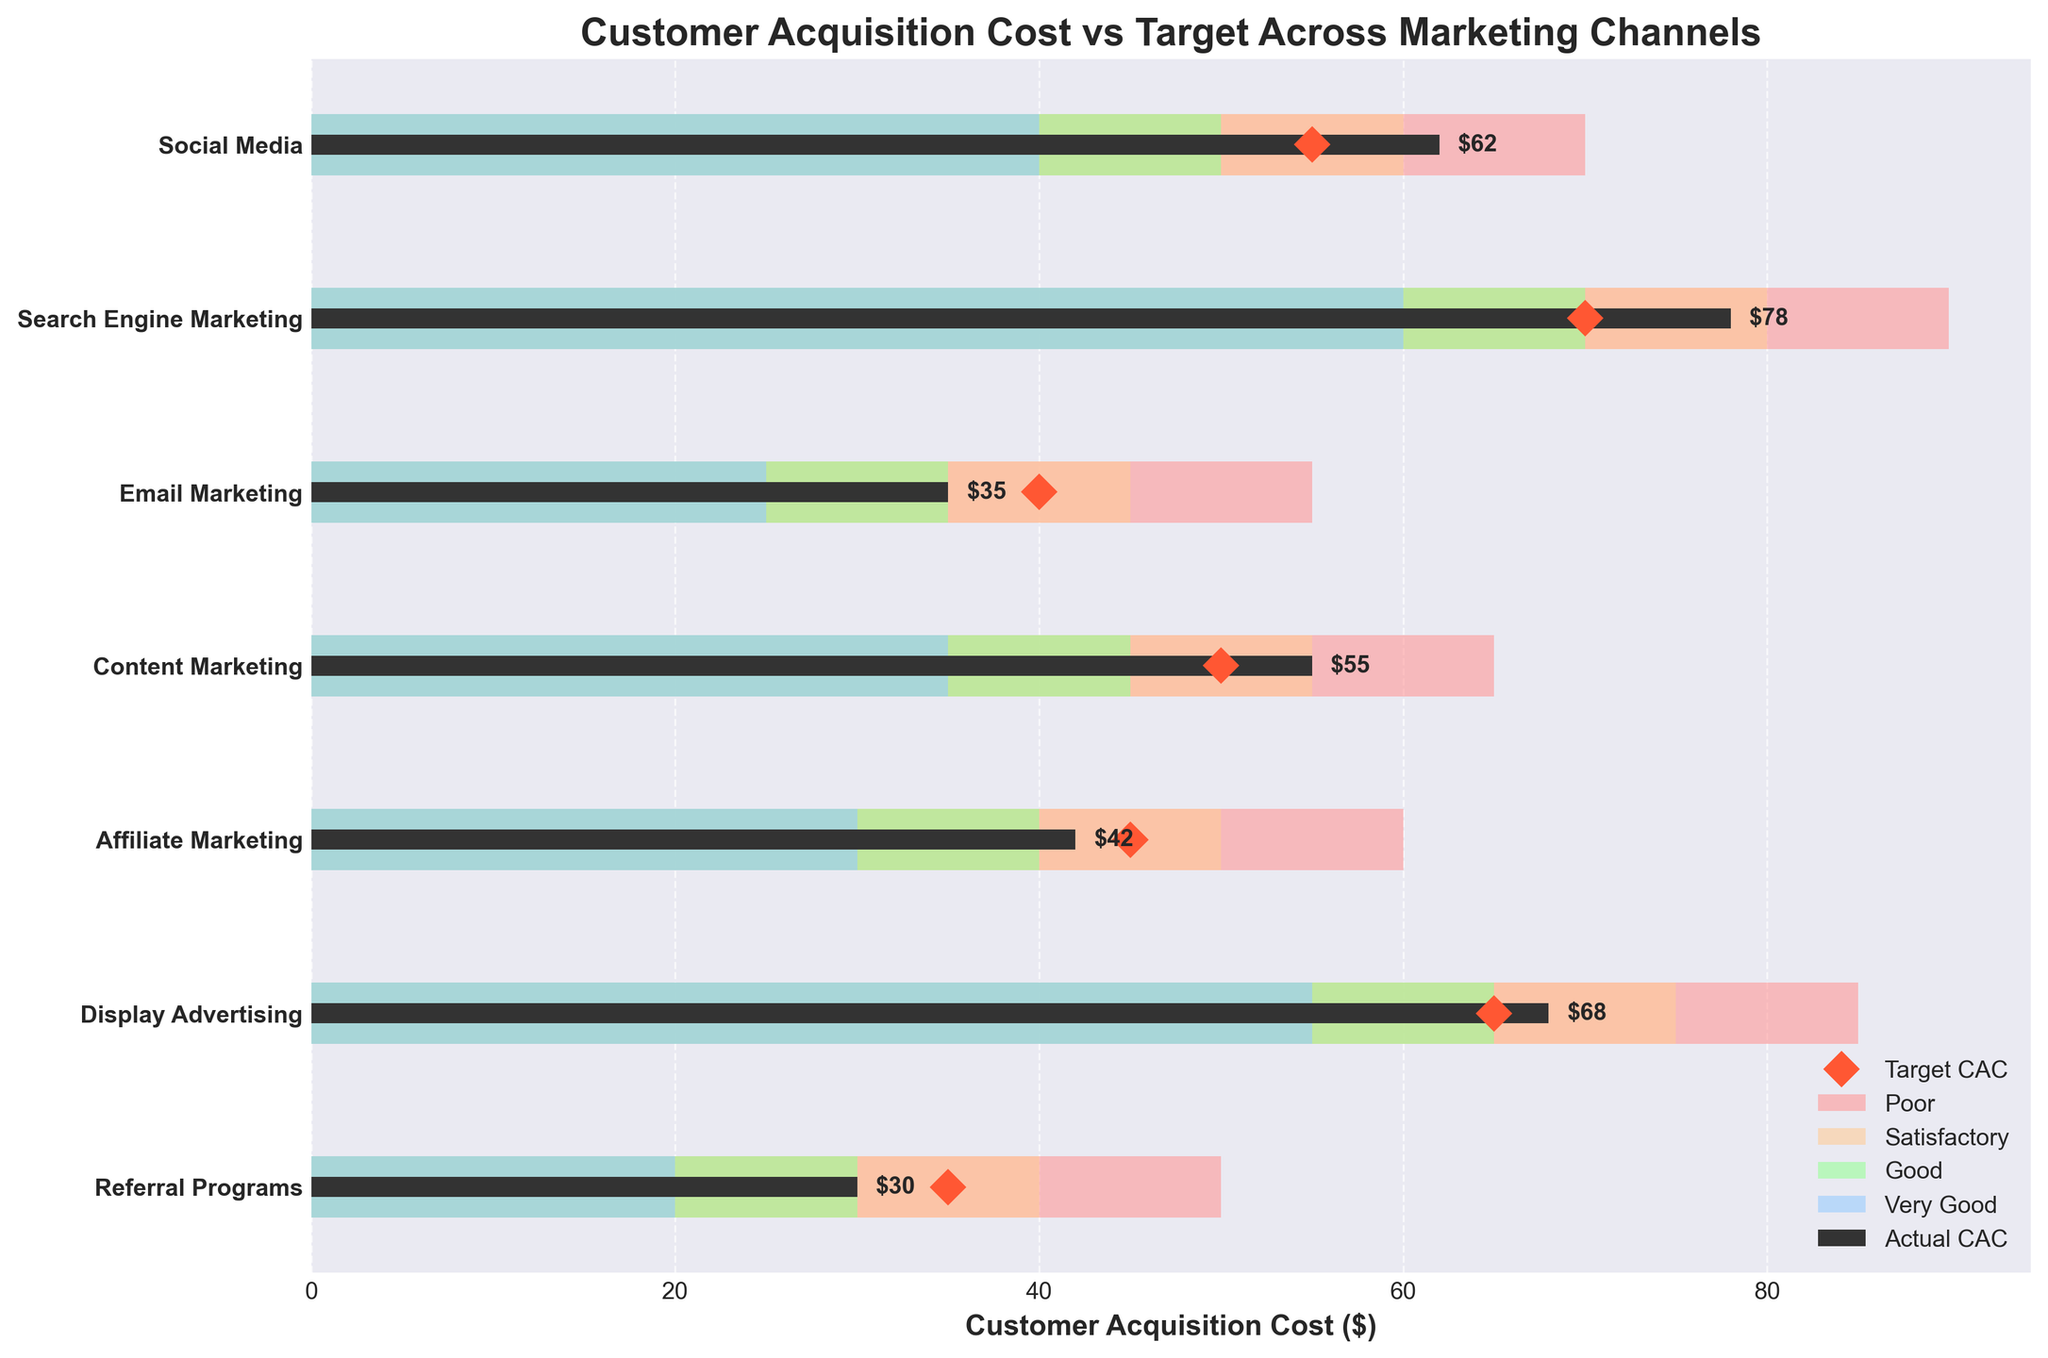What is the title of the figure? The title of the figure is displayed at the top. It describes the purpose or the main message the plot conveys.
Answer: Customer Acquisition Cost vs Target Across Marketing Channels Which marketing channel has the highest actual Customer Acquisition Cost (CAC)? By looking at the horizontal bars representing the actual CAC in dark color, we can identify the highest bar to find the channel with the highest CAC.
Answer: Search Engine Marketing What is the target CAC for Social Media? The target CAC is marked by a diamond shape for each channel, and we need to find the diamond corresponding to Social Media.
Answer: 55 Compare the actual CAC for Email Marketing and Content Marketing. Which one is lower? By observing the lengths of the horizontal bars representing the actual CAC for both channels, we can see which bar is shorter.
Answer: Email Marketing Which marketing channel has the actual CAC closest to the target CAC? By comparing the positions of the actual CAC bars and the diamond markers for each channel, we identify the channel with the closest values.
Answer: Email Marketing How many channels exceeded their target CAC? For each channel, if the actual CAC bar (dark color) extends beyond the diamond marker, it has exceeded the target. Count the number of such cases.
Answer: 4 In which channel does the actual CAC fall within the “Very Good” range? For each channel, if the actual CAC bar (dark color) falls within the blue segment labeled "Very Good," we identify that channel.
Answer: Referral Programs Calculate the difference between the actual and target CAC for Display Advertising. Subtract the target CAC value from the actual CAC value for Display Advertising. (68 - 65 = 3)
Answer: 3 Rank the channels based on actual CAC in ascending order. By observing and listing the lengths of the horizontal bars representing the actual CAC for all channels from shortest to longest.
Answer: Referral Programs, Email Marketing, Affiliate Marketing, Content Marketing, Social Media, Display Advertising, Search Engine Marketing Which channel’s CAC meets the "Good" criteria but is not less than the target CAC? Check the position of the dark actual CAC bar relative to the green "Good" segment and compare it to the diamond marker for each channel.
Answer: Content Marketing 